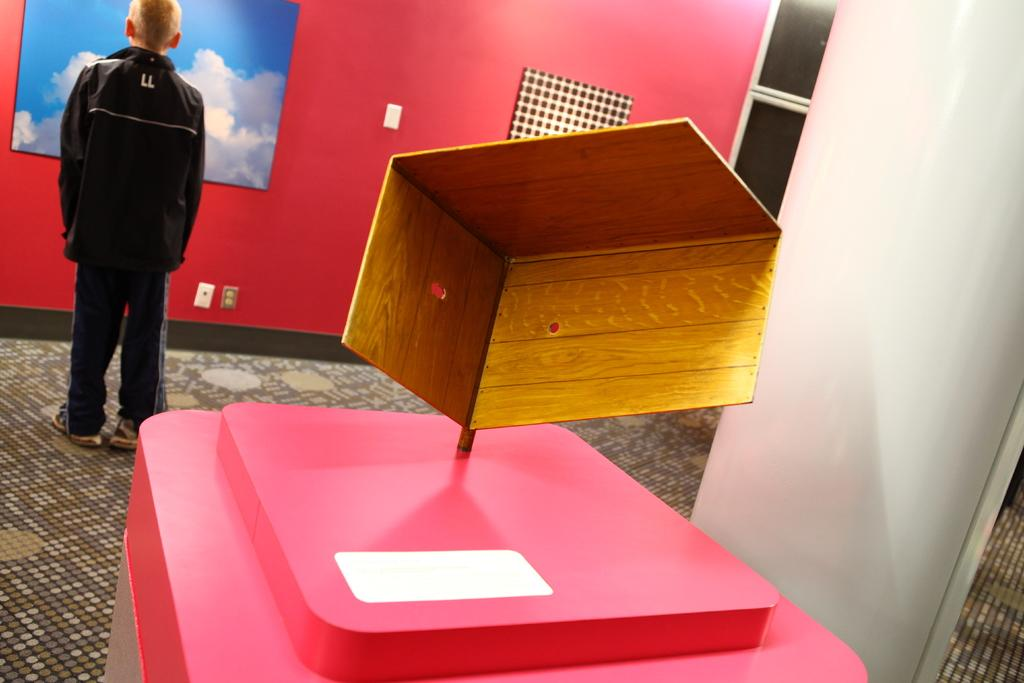What is the position of the boy in the image? The boy is standing on the left side of the image. What is the boy looking at in the image? The boy is looking at an image on the wall. What is the boy wearing in the image? The boy is wearing a black coat. What type of shelf can be seen on the right side of the image? There is no shelf present in the image; it only features the boy standing on the left side and looking at an image on the wall. 